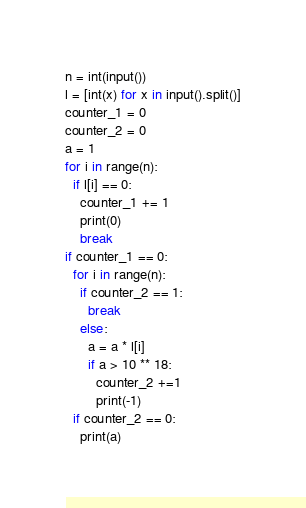<code> <loc_0><loc_0><loc_500><loc_500><_Python_>n = int(input())
l = [int(x) for x in input().split()]
counter_1 = 0
counter_2 = 0
a = 1
for i in range(n):
  if l[i] == 0:
    counter_1 += 1
    print(0)
    break
if counter_1 == 0:
  for i in range(n):
    if counter_2 == 1:
      break
    else:
      a = a * l[i]
      if a > 10 ** 18:
        counter_2 +=1
        print(-1)
  if counter_2 == 0:
    print(a)
</code> 